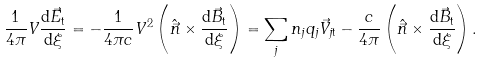Convert formula to latex. <formula><loc_0><loc_0><loc_500><loc_500>\frac { 1 } { 4 \pi } V \frac { \mathrm d \vec { E } _ { \mathrm t } } { \mathrm d \xi } = - \frac { 1 } { 4 \pi c } V ^ { 2 } \left ( \hat { \vec { n } } \times \frac { \mathrm d \vec { B } _ { \mathrm t } } { \mathrm d \xi } \right ) = \sum _ { j } n _ { j } q _ { j } { \vec { V } } _ { j \mathrm t } - \frac { c } { 4 \pi } \left ( \hat { \vec { n } } \times \frac { \mathrm d { \vec { B } } _ { \mathrm t } } { \mathrm d \xi } \right ) .</formula> 